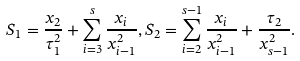Convert formula to latex. <formula><loc_0><loc_0><loc_500><loc_500>S _ { 1 } = \frac { x _ { 2 } } { \tau _ { 1 } ^ { 2 } } + \sum _ { i = 3 } ^ { s } \frac { x _ { i } } { x _ { i - 1 } ^ { 2 } } , S _ { 2 } = \sum _ { i = 2 } ^ { s - 1 } \frac { x _ { i } } { x _ { i - 1 } ^ { 2 } } + \frac { \tau _ { 2 } } { x _ { s - 1 } ^ { 2 } } .</formula> 